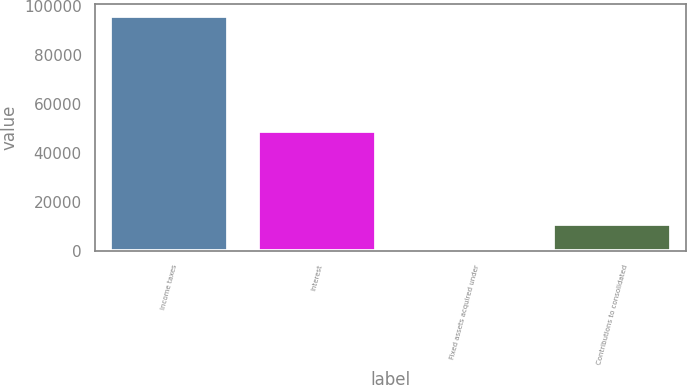Convert chart to OTSL. <chart><loc_0><loc_0><loc_500><loc_500><bar_chart><fcel>Income taxes<fcel>Interest<fcel>Fixed assets acquired under<fcel>Contributions to consolidated<nl><fcel>95943<fcel>48822<fcel>1295<fcel>10759.8<nl></chart> 